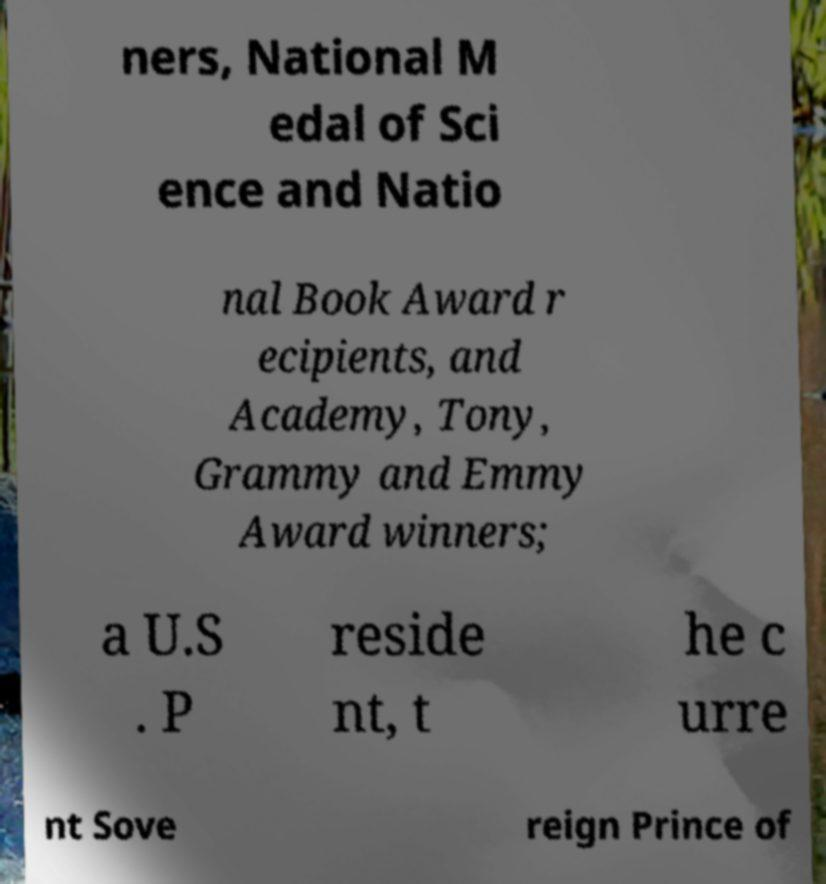Please identify and transcribe the text found in this image. ners, National M edal of Sci ence and Natio nal Book Award r ecipients, and Academy, Tony, Grammy and Emmy Award winners; a U.S . P reside nt, t he c urre nt Sove reign Prince of 